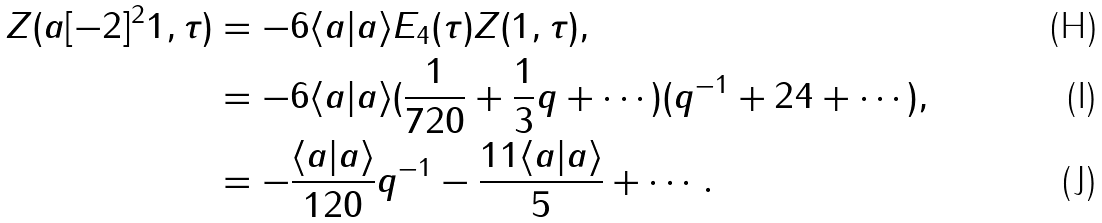Convert formula to latex. <formula><loc_0><loc_0><loc_500><loc_500>Z ( a [ - 2 ] ^ { 2 } 1 , \tau ) & = - 6 \langle a | a \rangle E _ { 4 } ( \tau ) Z ( 1 , \tau ) , \\ & = - 6 \langle a | a \rangle ( \frac { 1 } { 7 2 0 } + \frac { 1 } { 3 } q + \cdots ) ( q ^ { - 1 } + 2 4 + \cdots ) , \\ & = - \frac { \langle a | a \rangle } { 1 2 0 } q ^ { - 1 } - \frac { 1 1 \langle a | a \rangle } { 5 } + \cdots .</formula> 